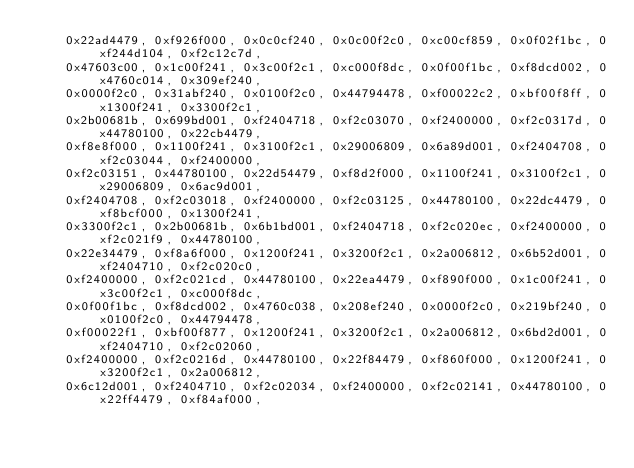<code> <loc_0><loc_0><loc_500><loc_500><_C_>    0x22ad4479, 0xf926f000, 0x0c0cf240, 0x0c00f2c0, 0xc00cf859, 0x0f02f1bc, 0xf244d104, 0xf2c12c7d,
    0x47603c00, 0x1c00f241, 0x3c00f2c1, 0xc000f8dc, 0x0f00f1bc, 0xf8dcd002, 0x4760c014, 0x309ef240,
    0x0000f2c0, 0x31abf240, 0x0100f2c0, 0x44794478, 0xf00022c2, 0xbf00f8ff, 0x1300f241, 0x3300f2c1,
    0x2b00681b, 0x699bd001, 0xf2404718, 0xf2c03070, 0xf2400000, 0xf2c0317d, 0x44780100, 0x22cb4479,
    0xf8e8f000, 0x1100f241, 0x3100f2c1, 0x29006809, 0x6a89d001, 0xf2404708, 0xf2c03044, 0xf2400000,
    0xf2c03151, 0x44780100, 0x22d54479, 0xf8d2f000, 0x1100f241, 0x3100f2c1, 0x29006809, 0x6ac9d001,
    0xf2404708, 0xf2c03018, 0xf2400000, 0xf2c03125, 0x44780100, 0x22dc4479, 0xf8bcf000, 0x1300f241,
    0x3300f2c1, 0x2b00681b, 0x6b1bd001, 0xf2404718, 0xf2c020ec, 0xf2400000, 0xf2c021f9, 0x44780100,
    0x22e34479, 0xf8a6f000, 0x1200f241, 0x3200f2c1, 0x2a006812, 0x6b52d001, 0xf2404710, 0xf2c020c0,
    0xf2400000, 0xf2c021cd, 0x44780100, 0x22ea4479, 0xf890f000, 0x1c00f241, 0x3c00f2c1, 0xc000f8dc,
    0x0f00f1bc, 0xf8dcd002, 0x4760c038, 0x208ef240, 0x0000f2c0, 0x219bf240, 0x0100f2c0, 0x44794478,
    0xf00022f1, 0xbf00f877, 0x1200f241, 0x3200f2c1, 0x2a006812, 0x6bd2d001, 0xf2404710, 0xf2c02060,
    0xf2400000, 0xf2c0216d, 0x44780100, 0x22f84479, 0xf860f000, 0x1200f241, 0x3200f2c1, 0x2a006812,
    0x6c12d001, 0xf2404710, 0xf2c02034, 0xf2400000, 0xf2c02141, 0x44780100, 0x22ff4479, 0xf84af000,</code> 